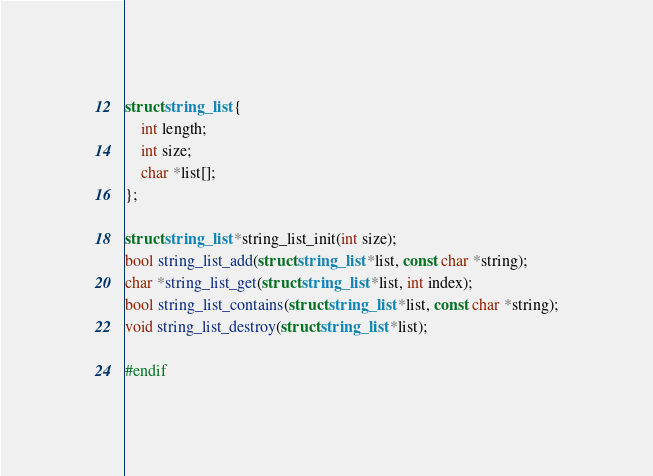Convert code to text. <code><loc_0><loc_0><loc_500><loc_500><_C_>struct string_list {
	int length;
	int size;
	char *list[];
};

struct string_list *string_list_init(int size);
bool string_list_add(struct string_list *list, const char *string);
char *string_list_get(struct string_list *list, int index);
bool string_list_contains(struct string_list *list, const char *string);
void string_list_destroy(struct string_list *list);

#endif
</code> 